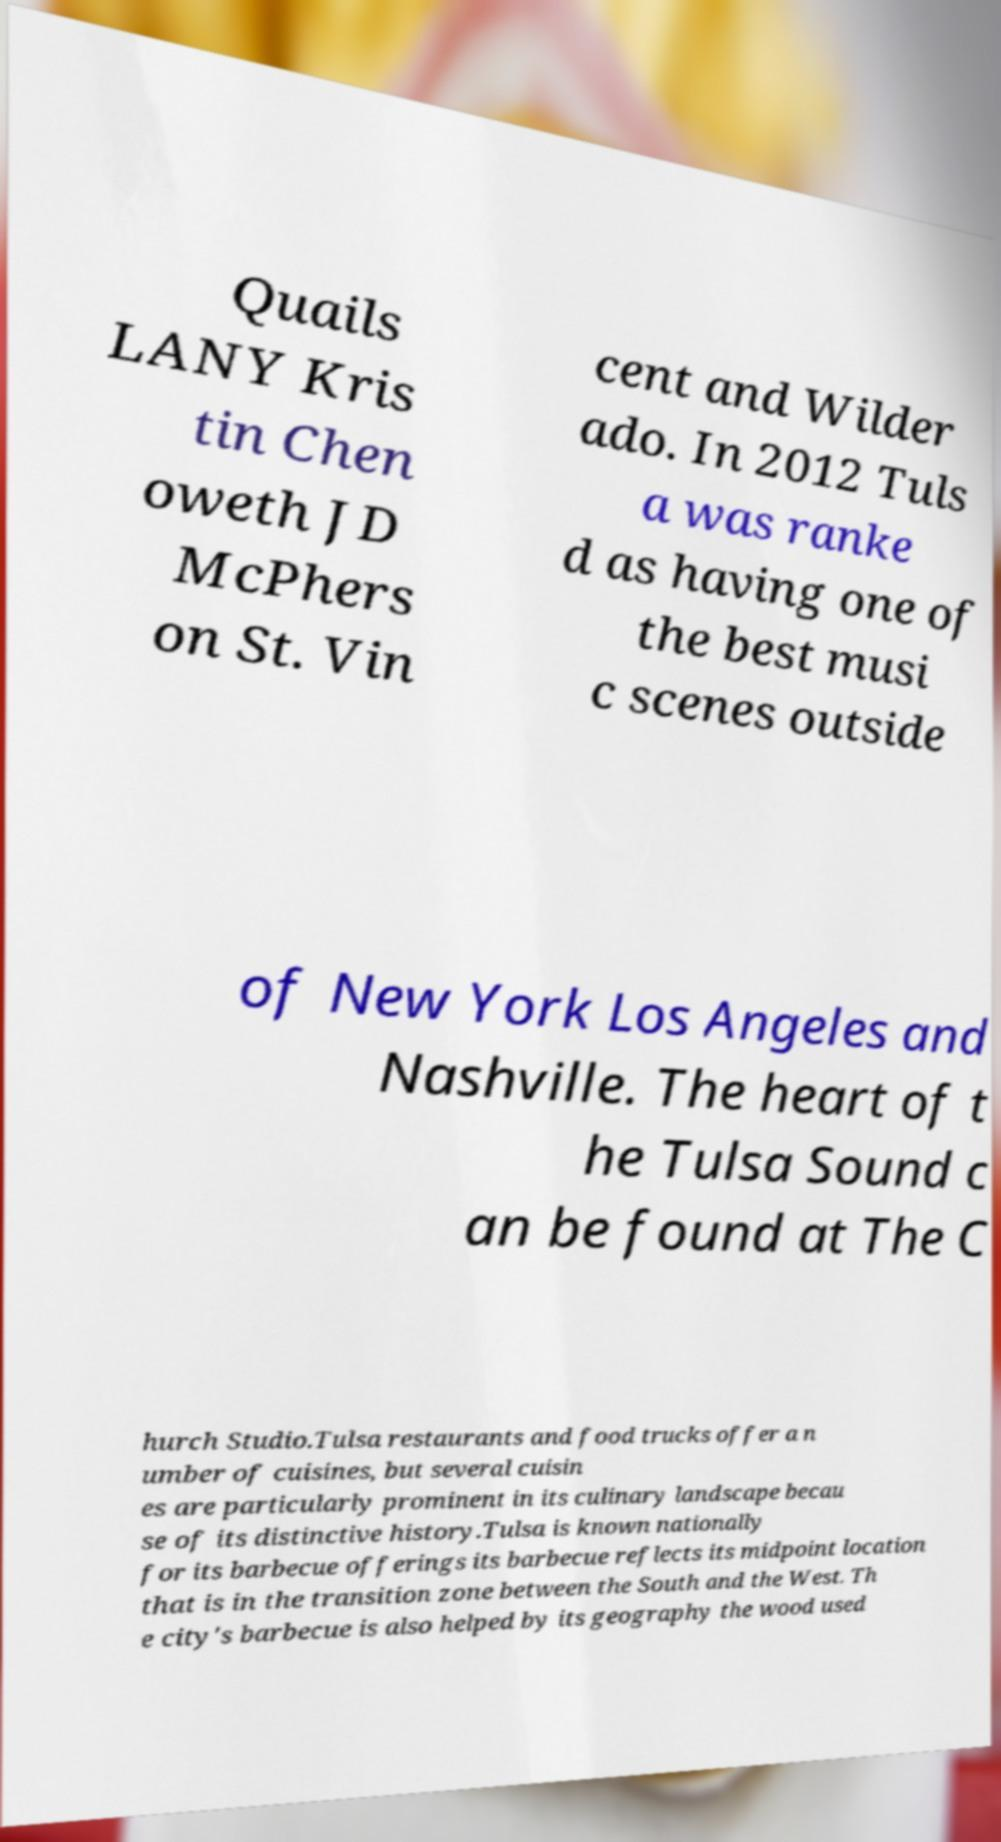Please identify and transcribe the text found in this image. Quails LANY Kris tin Chen oweth JD McPhers on St. Vin cent and Wilder ado. In 2012 Tuls a was ranke d as having one of the best musi c scenes outside of New York Los Angeles and Nashville. The heart of t he Tulsa Sound c an be found at The C hurch Studio.Tulsa restaurants and food trucks offer a n umber of cuisines, but several cuisin es are particularly prominent in its culinary landscape becau se of its distinctive history.Tulsa is known nationally for its barbecue offerings its barbecue reflects its midpoint location that is in the transition zone between the South and the West. Th e city's barbecue is also helped by its geography the wood used 